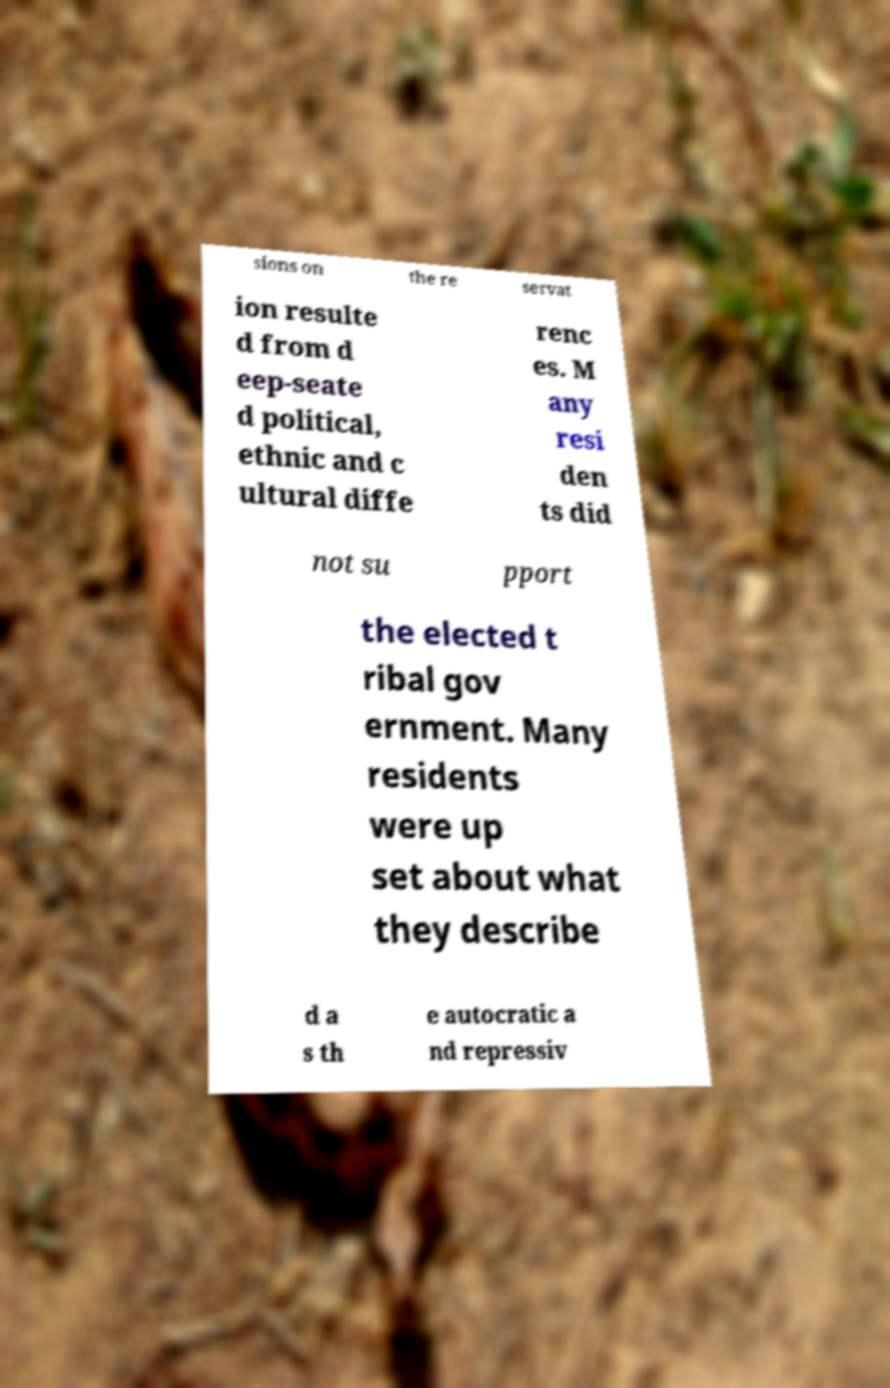Please read and relay the text visible in this image. What does it say? sions on the re servat ion resulte d from d eep-seate d political, ethnic and c ultural diffe renc es. M any resi den ts did not su pport the elected t ribal gov ernment. Many residents were up set about what they describe d a s th e autocratic a nd repressiv 